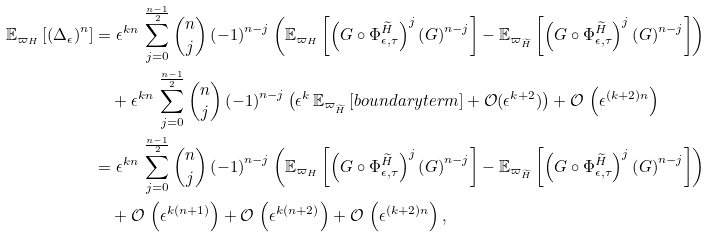Convert formula to latex. <formula><loc_0><loc_0><loc_500><loc_500>\mathbb { E } _ { \varpi _ { H } } \left [ \left ( \Delta _ { \epsilon } \right ) ^ { n } \right ] & = \epsilon ^ { k n } \, \sum _ { j = 0 } ^ { \frac { n - 1 } { 2 } } \binom { n } { j } \left ( - 1 \right ) ^ { n - j } \left ( \mathbb { E } _ { \varpi _ { H } } \left [ \left ( G \circ \Phi ^ { \widetilde { H } } _ { \epsilon , \tau } \right ) ^ { j } \left ( G \right ) ^ { n - j } \right ] - \mathbb { E } _ { \varpi _ { \widetilde { H } } } \left [ \left ( G \circ \Phi ^ { \widetilde { H } } _ { \epsilon , \tau } \right ) ^ { j } \left ( G \right ) ^ { n - j } \right ] \right ) \\ & \quad + \epsilon ^ { k n } \, \sum _ { j = 0 } ^ { \frac { n - 1 } { 2 } } \binom { n } { j } \left ( - 1 \right ) ^ { n - j } \left ( \epsilon ^ { k } \, \mathbb { E } _ { \varpi _ { \widetilde { H } } } \left [ b o u n d a r y t e r m \right ] + \mathcal { O } ( \epsilon ^ { k + 2 } ) \right ) + \mathcal { O } \, \left ( \epsilon ^ { ( k + 2 ) n } \right ) \\ & = \epsilon ^ { k n } \, \sum _ { j = 0 } ^ { \frac { n - 1 } { 2 } } \binom { n } { j } \left ( - 1 \right ) ^ { n - j } \left ( \mathbb { E } _ { \varpi _ { H } } \left [ \left ( G \circ \Phi ^ { \widetilde { H } } _ { \epsilon , \tau } \right ) ^ { j } \left ( G \right ) ^ { n - j } \right ] - \mathbb { E } _ { \varpi _ { \widetilde { H } } } \left [ \left ( G \circ \Phi ^ { \widetilde { H } } _ { \epsilon , \tau } \right ) ^ { j } \left ( G \right ) ^ { n - j } \right ] \right ) \\ & \quad + \mathcal { O } \, \left ( \epsilon ^ { k ( n + 1 ) } \right ) + \mathcal { O } \, \left ( \epsilon ^ { k ( n + 2 ) } \right ) + \mathcal { O } \, \left ( \epsilon ^ { ( k + 2 ) n } \right ) ,</formula> 